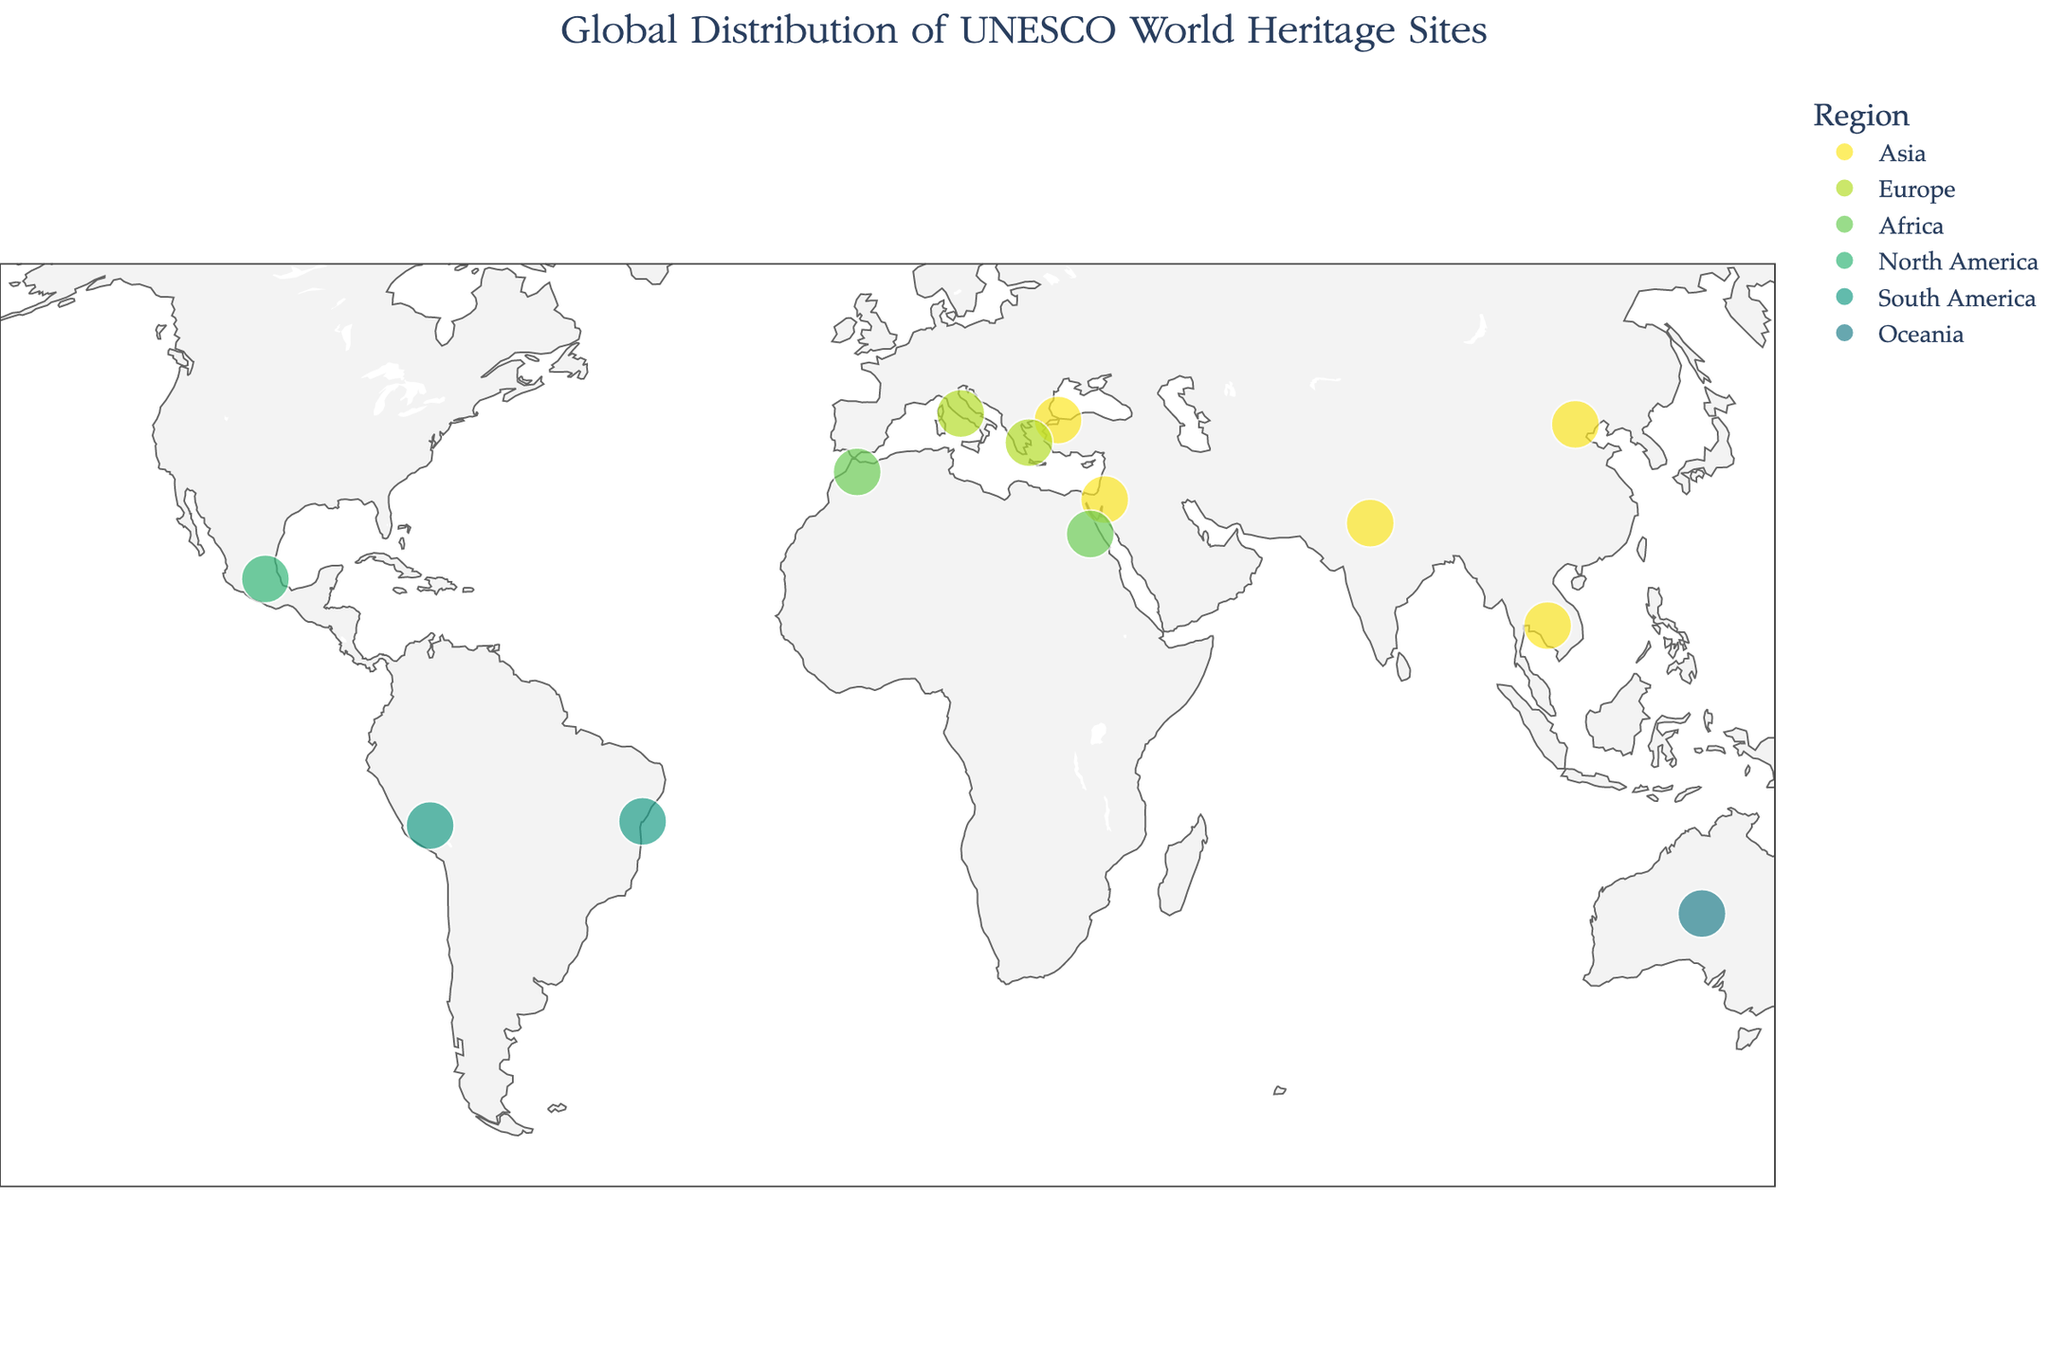How many UNESCO World Heritage Sites are shown on the map? Count the number of data points on the map. Each data point represents a UNESCO World Heritage Site.
Answer: 13 Which regions have the most and the least number of UNESCO World Heritage Sites on this map? Group the UNESCO World Heritage Sites by their region and count the number of sites in each region.
Answer: Most: Asia, Least: Oceania What is the title of the map? Look at the top of the map where the title is displayed.
Answer: Global Distribution of UNESCO World Heritage Sites Which UNESCO World Heritage Site is located furthest to the south? Identify the site with the lowest latitude value.
Answer: City of Cusco (Peru) How many UNESCO World Heritage Sites in Europe are shown on the map? Count the number of data points labeled as being in Europe.
Answer: 2 Which site was inscribed the earliest and in what year? Identify the site with the earliest inscription year by examining the hover information for each data point.
Answer: Ancient Thebes with its Necropolis (1979) Which two sites are geographically closest to each other, judging by their positions on the map? Look for the two sites that are positioned closest together on the geographic plot.
Answer: Great Wall of China and Historic Areas of Istanbul What colors are used to represent different regions on the map? Examine the color of each data point and match it to its corresponding region as given in the data.
Answer: Variations of the Viridis color scale, e.g., shades from yellow to blue-green What annotation is added to each UNESCO World Heritage Site on the map? Look at the additional text near each data point.
Answer: The name of the Cultural Site How is the map visually enhanced to help differentiate countries and regions? Look at the visual layout components including land color, country boundaries, coastline color, and geographic annotations.
Answer: Land color is light gray, country boundaries are light gray, and coastlines are a darker gray 